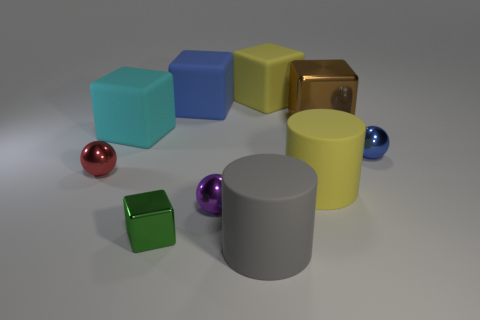Subtract all purple metal balls. How many balls are left? 2 Subtract 1 cubes. How many cubes are left? 4 Subtract all yellow blocks. How many blocks are left? 4 Subtract all green blocks. Subtract all gray cylinders. How many blocks are left? 4 Subtract 1 blue blocks. How many objects are left? 9 Subtract all spheres. How many objects are left? 7 Subtract all purple metal spheres. Subtract all large gray shiny things. How many objects are left? 9 Add 4 large gray things. How many large gray things are left? 5 Add 8 gray rubber blocks. How many gray rubber blocks exist? 8 